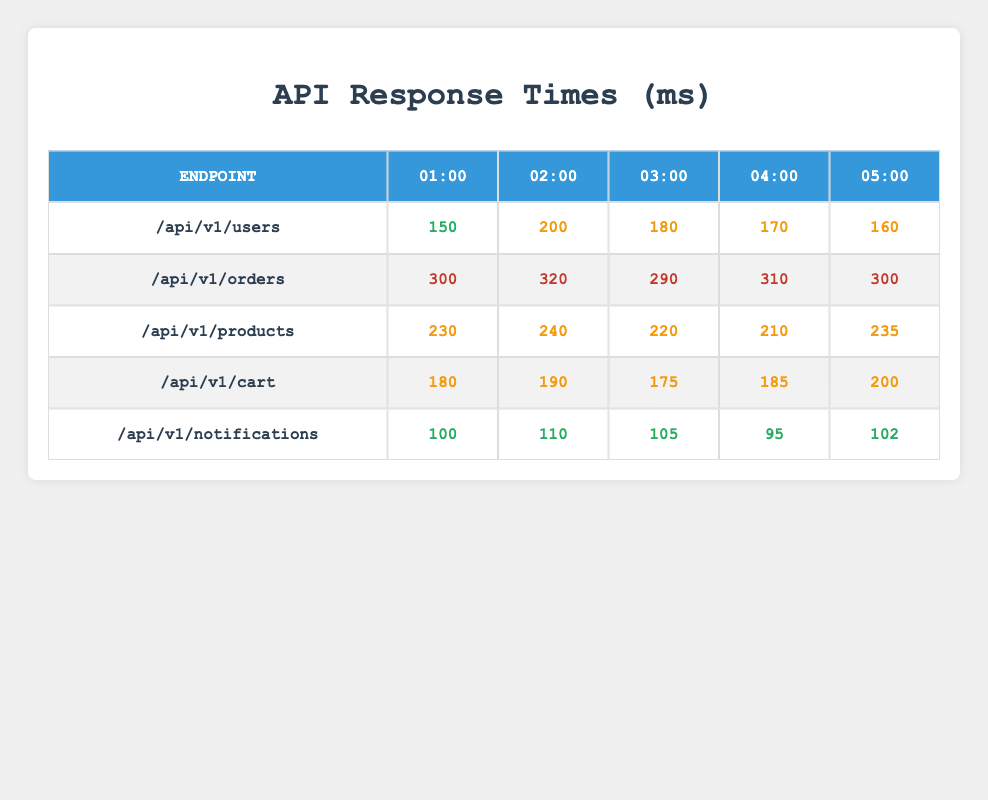What is the response time for the /api/v1/notifications endpoint at 04:00? According to the table, the response time for the /api/v1/notifications endpoint at 04:00 is 95 milliseconds.
Answer: 95 ms Which endpoint has the highest response time at 02:00? By looking at the table, at 02:00 the response times are: /api/v1/users (200 ms), /api/v1/orders (320 ms), /api/v1/products (240 ms), /api/v1/cart (190 ms), and /api/v1/notifications (110 ms). The highest is 320 ms for /api/v1/orders.
Answer: /api/v1/orders What is the average response time for the /api/v1/products endpoint over the reported hours? The response times for the /api/v1/products endpoint are: 230, 240, 220, 210, and 235 ms. To find the average, sum these values (230 + 240 + 220 + 210 + 235 = 1135) and divide by the number of entries (5), resulting in an average of 227 ms.
Answer: 227 ms Is the response time for the /api/v1/cart endpoint consistent across all hours? The response times for /api/v1/cart are: 180, 190, 175, 185, and 200 ms. Since these values vary, we can conclude that the response time is not consistent.
Answer: No What is the total response time for all endpoints at 01:00? The response times at 01:00 are: /api/v1/users (150 ms), /api/v1/orders (300 ms), /api/v1/products (230 ms), /api/v1/cart (180 ms), and /api/v1/notifications (100 ms). Adding these gives: 150 + 300 + 230 + 180 + 100 = 960 ms.
Answer: 960 ms Which endpoint shows the least improvement over time? We compare the response times at 01:00 (150 ms) to 05:00 (160 ms) for /api/v1/users, at 01:00 (300 ms) to 05:00 (300 ms) for /api/v1/orders, and so on. The endpoint with the least improvement is /api/v1/orders, which shows no change.
Answer: /api/v1/orders What is the maximum response time across all endpoints and hours? We examine the response times: the highest recorded value is 320 ms at 02:00 for the /api/v1/orders endpoint. Thus, the maximum response time overall is 320 ms.
Answer: 320 ms Which endpoint has the best average response time throughout the reporting hours? Calculating the average response times: /api/v1/users: 170 ms; /api/v1/orders: 306 ms; /api/v1/products: 226 ms; /api/v1/cart: 185 ms; /api/v1/notifications: 103 ms. The best average is for /api/v1/notifications at 103 ms.
Answer: /api/v1/notifications 